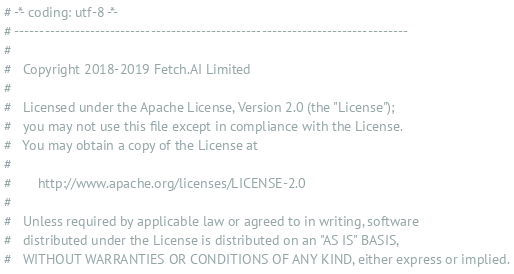<code> <loc_0><loc_0><loc_500><loc_500><_Python_># -*- coding: utf-8 -*-
# ------------------------------------------------------------------------------
#
#   Copyright 2018-2019 Fetch.AI Limited
#
#   Licensed under the Apache License, Version 2.0 (the "License");
#   you may not use this file except in compliance with the License.
#   You may obtain a copy of the License at
#
#       http://www.apache.org/licenses/LICENSE-2.0
#
#   Unless required by applicable law or agreed to in writing, software
#   distributed under the License is distributed on an "AS IS" BASIS,
#   WITHOUT WARRANTIES OR CONDITIONS OF ANY KIND, either express or implied.</code> 